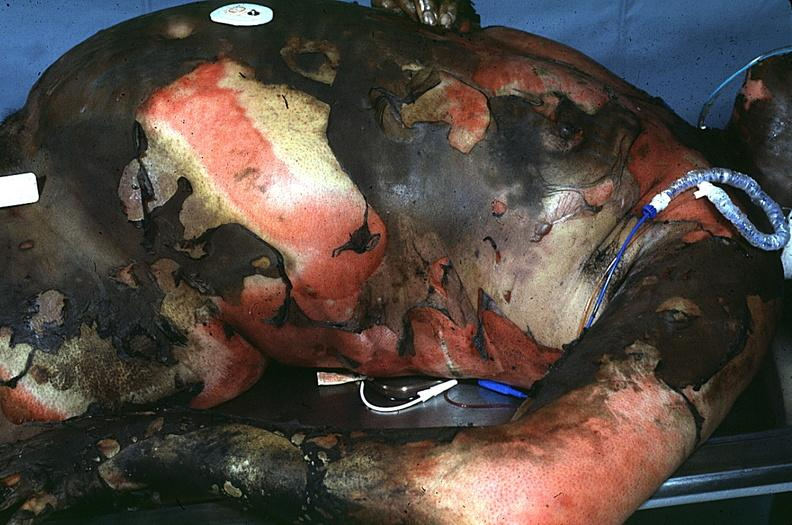do yellow color burn?
Answer the question using a single word or phrase. No 